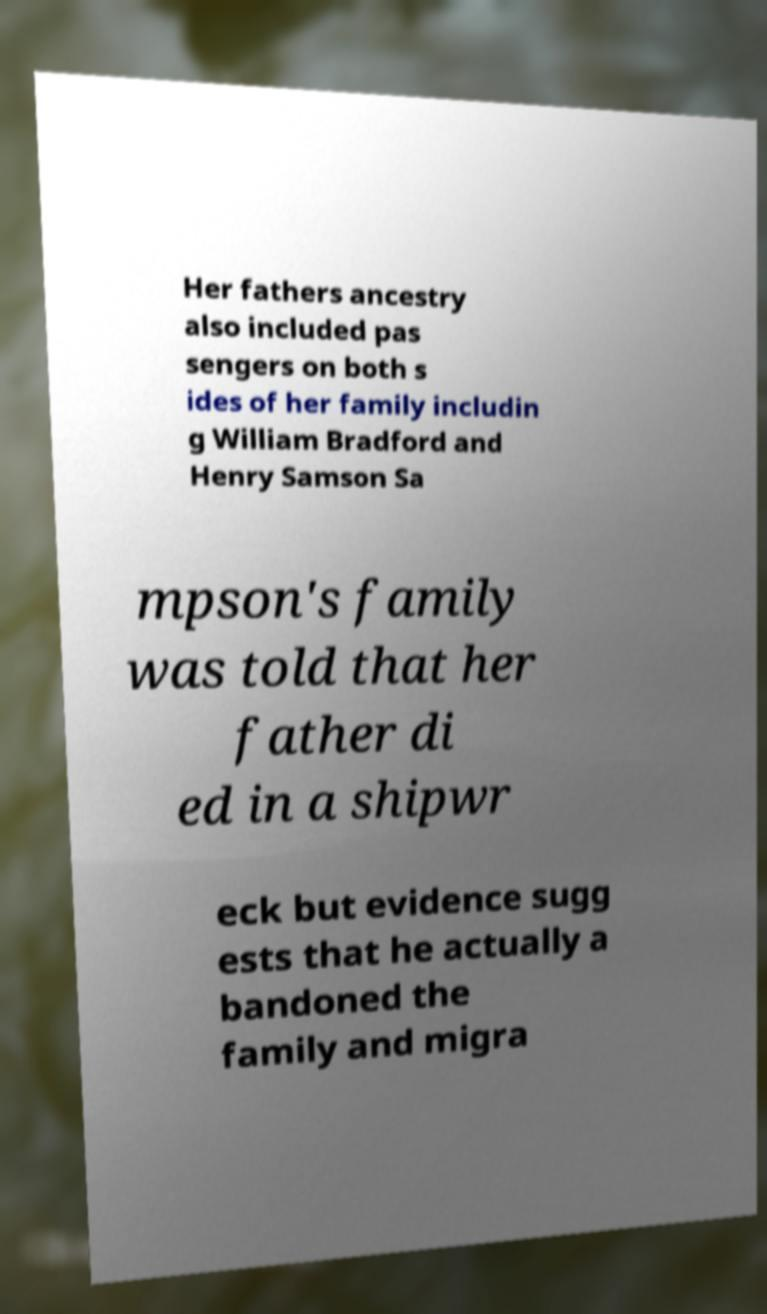Could you assist in decoding the text presented in this image and type it out clearly? Her fathers ancestry also included pas sengers on both s ides of her family includin g William Bradford and Henry Samson Sa mpson's family was told that her father di ed in a shipwr eck but evidence sugg ests that he actually a bandoned the family and migra 